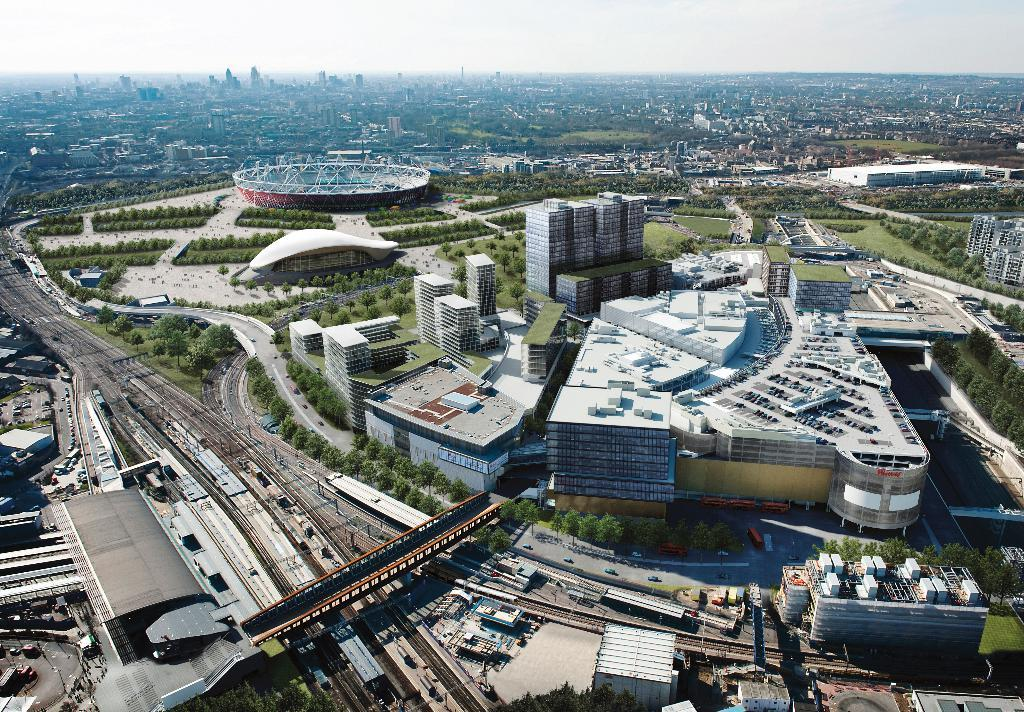What type of structures can be seen in the image? There are buildings in the image. What else is present in the image besides buildings? There are vehicles, trees, poles, a bridge, and shrubs in the image. Can you describe the type of transportation visible in the image? The vehicles in the image are the mode of transportation. What natural elements can be seen in the image? Trees and shrubs are the natural elements visible in the image. What type of scent can be detected from the clover in the image? There is no clover present in the image, so no scent can be detected. What type of land is visible in the image? The image does not show any specific type of land; it contains buildings, vehicles, trees, poles, a bridge, and shrubs. 